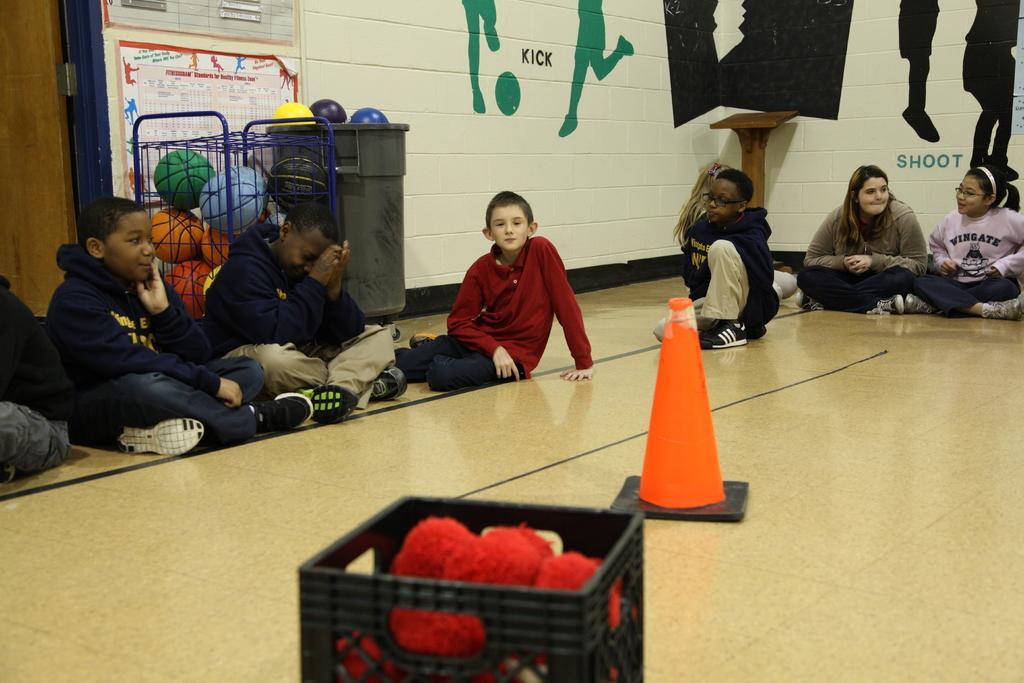Can you describe this image briefly? These people are sitting on the floor. On this floor there are containers and traffic cones. In that containers there are balls. Posters and paintings are on the wall. In-front of this wall there is a podium. 